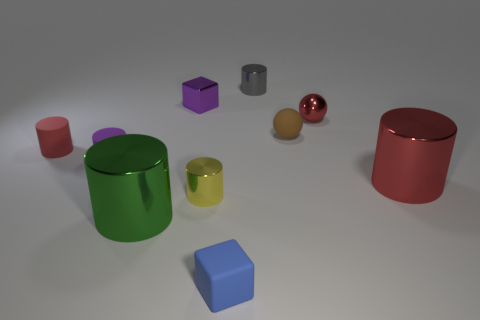The small thing that is the same color as the shiny block is what shape?
Your response must be concise. Cylinder. Is the shape of the red metallic thing behind the brown matte object the same as the big object that is right of the small matte cube?
Provide a succinct answer. No. Are there any tiny rubber spheres to the left of the yellow shiny object?
Provide a short and direct response. No. What is the color of the other thing that is the same shape as the blue object?
Offer a very short reply. Purple. Are there any other things that have the same shape as the tiny blue thing?
Ensure brevity in your answer.  Yes. What material is the red cylinder that is to the left of the purple metal object?
Give a very brief answer. Rubber. The shiny object that is the same shape as the brown rubber object is what size?
Your answer should be very brief. Small. What number of small things are the same material as the small purple cylinder?
Offer a terse response. 3. What number of metallic cylinders have the same color as the tiny metallic ball?
Your answer should be compact. 1. How many things are tiny metal objects to the left of the tiny brown matte object or large red things that are to the right of the blue object?
Offer a very short reply. 4. 